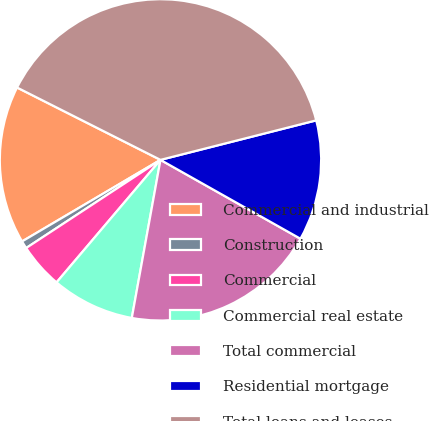Convert chart to OTSL. <chart><loc_0><loc_0><loc_500><loc_500><pie_chart><fcel>Commercial and industrial<fcel>Construction<fcel>Commercial<fcel>Commercial real estate<fcel>Total commercial<fcel>Residential mortgage<fcel>Total loans and leases<nl><fcel>15.91%<fcel>0.77%<fcel>4.56%<fcel>8.34%<fcel>19.69%<fcel>12.12%<fcel>38.61%<nl></chart> 